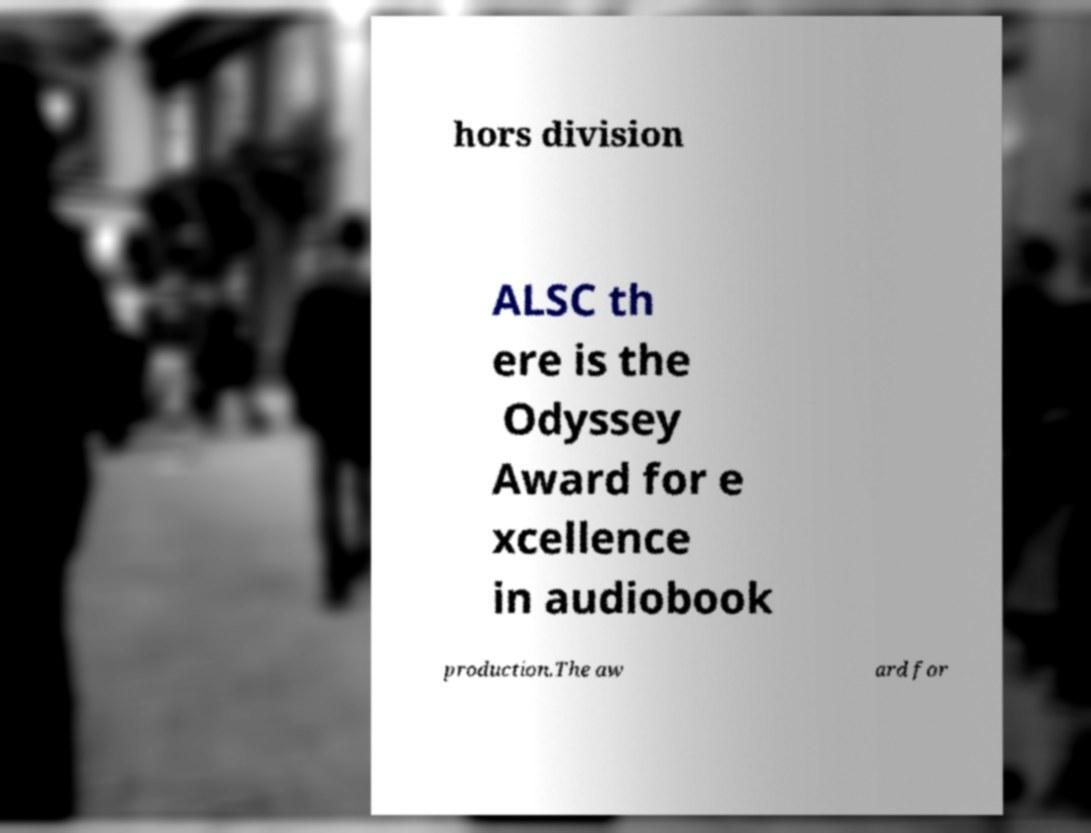Can you read and provide the text displayed in the image?This photo seems to have some interesting text. Can you extract and type it out for me? hors division ALSC th ere is the Odyssey Award for e xcellence in audiobook production.The aw ard for 